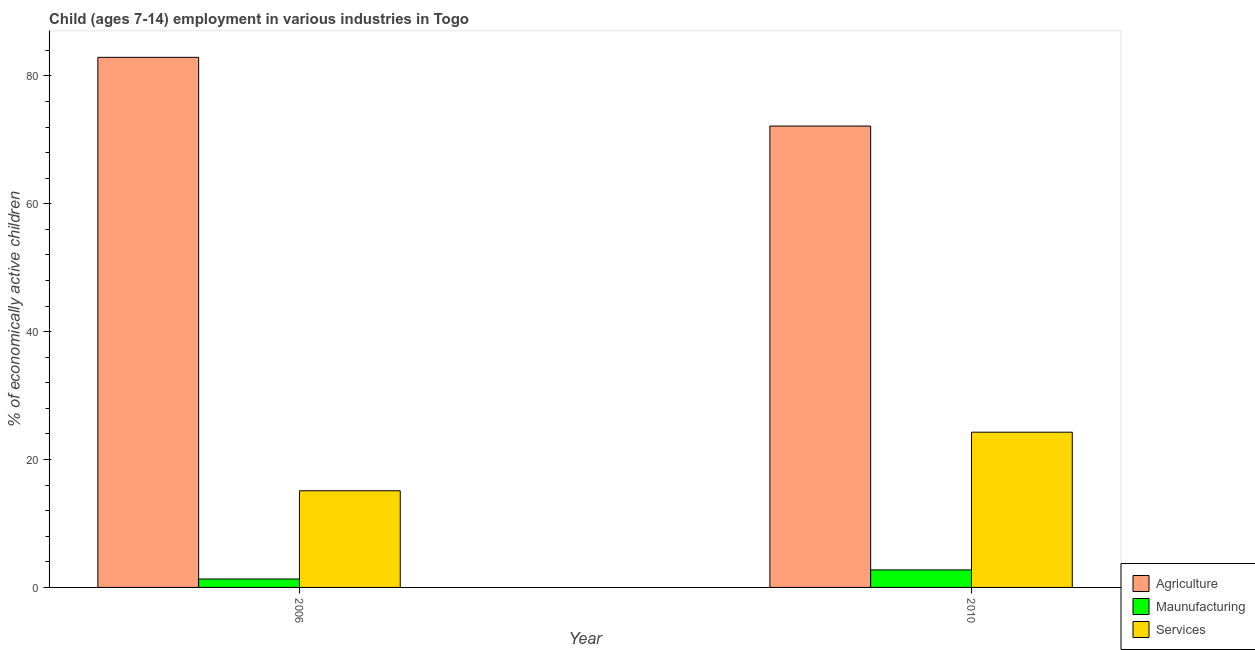How many different coloured bars are there?
Make the answer very short. 3. How many groups of bars are there?
Keep it short and to the point. 2. In how many cases, is the number of bars for a given year not equal to the number of legend labels?
Offer a terse response. 0. What is the percentage of economically active children in manufacturing in 2010?
Offer a very short reply. 2.74. Across all years, what is the maximum percentage of economically active children in agriculture?
Make the answer very short. 82.91. Across all years, what is the minimum percentage of economically active children in agriculture?
Offer a terse response. 72.16. In which year was the percentage of economically active children in agriculture minimum?
Provide a short and direct response. 2010. What is the total percentage of economically active children in services in the graph?
Keep it short and to the point. 39.4. What is the difference between the percentage of economically active children in services in 2006 and that in 2010?
Your answer should be compact. -9.16. What is the difference between the percentage of economically active children in manufacturing in 2010 and the percentage of economically active children in agriculture in 2006?
Make the answer very short. 1.42. What is the average percentage of economically active children in agriculture per year?
Your response must be concise. 77.53. In the year 2006, what is the difference between the percentage of economically active children in agriculture and percentage of economically active children in services?
Provide a succinct answer. 0. In how many years, is the percentage of economically active children in agriculture greater than 68 %?
Offer a terse response. 2. What is the ratio of the percentage of economically active children in services in 2006 to that in 2010?
Offer a terse response. 0.62. In how many years, is the percentage of economically active children in services greater than the average percentage of economically active children in services taken over all years?
Offer a very short reply. 1. What does the 2nd bar from the left in 2006 represents?
Offer a terse response. Maunufacturing. What does the 3rd bar from the right in 2010 represents?
Offer a terse response. Agriculture. Is it the case that in every year, the sum of the percentage of economically active children in agriculture and percentage of economically active children in manufacturing is greater than the percentage of economically active children in services?
Your response must be concise. Yes. How many years are there in the graph?
Your answer should be very brief. 2. Does the graph contain any zero values?
Offer a very short reply. No. Does the graph contain grids?
Provide a succinct answer. No. What is the title of the graph?
Offer a terse response. Child (ages 7-14) employment in various industries in Togo. Does "Financial account" appear as one of the legend labels in the graph?
Offer a very short reply. No. What is the label or title of the Y-axis?
Offer a terse response. % of economically active children. What is the % of economically active children of Agriculture in 2006?
Provide a succinct answer. 82.91. What is the % of economically active children in Maunufacturing in 2006?
Your answer should be very brief. 1.32. What is the % of economically active children in Services in 2006?
Keep it short and to the point. 15.12. What is the % of economically active children of Agriculture in 2010?
Offer a terse response. 72.16. What is the % of economically active children of Maunufacturing in 2010?
Your response must be concise. 2.74. What is the % of economically active children of Services in 2010?
Your answer should be compact. 24.28. Across all years, what is the maximum % of economically active children of Agriculture?
Make the answer very short. 82.91. Across all years, what is the maximum % of economically active children of Maunufacturing?
Ensure brevity in your answer.  2.74. Across all years, what is the maximum % of economically active children of Services?
Your answer should be very brief. 24.28. Across all years, what is the minimum % of economically active children in Agriculture?
Provide a short and direct response. 72.16. Across all years, what is the minimum % of economically active children in Maunufacturing?
Your response must be concise. 1.32. Across all years, what is the minimum % of economically active children in Services?
Make the answer very short. 15.12. What is the total % of economically active children of Agriculture in the graph?
Your response must be concise. 155.07. What is the total % of economically active children in Maunufacturing in the graph?
Give a very brief answer. 4.06. What is the total % of economically active children in Services in the graph?
Provide a succinct answer. 39.4. What is the difference between the % of economically active children of Agriculture in 2006 and that in 2010?
Offer a very short reply. 10.75. What is the difference between the % of economically active children in Maunufacturing in 2006 and that in 2010?
Your answer should be very brief. -1.42. What is the difference between the % of economically active children of Services in 2006 and that in 2010?
Your answer should be very brief. -9.16. What is the difference between the % of economically active children of Agriculture in 2006 and the % of economically active children of Maunufacturing in 2010?
Keep it short and to the point. 80.17. What is the difference between the % of economically active children in Agriculture in 2006 and the % of economically active children in Services in 2010?
Provide a short and direct response. 58.63. What is the difference between the % of economically active children of Maunufacturing in 2006 and the % of economically active children of Services in 2010?
Provide a short and direct response. -22.96. What is the average % of economically active children in Agriculture per year?
Ensure brevity in your answer.  77.53. What is the average % of economically active children of Maunufacturing per year?
Keep it short and to the point. 2.03. What is the average % of economically active children in Services per year?
Offer a terse response. 19.7. In the year 2006, what is the difference between the % of economically active children in Agriculture and % of economically active children in Maunufacturing?
Provide a succinct answer. 81.59. In the year 2006, what is the difference between the % of economically active children of Agriculture and % of economically active children of Services?
Give a very brief answer. 67.79. In the year 2010, what is the difference between the % of economically active children of Agriculture and % of economically active children of Maunufacturing?
Your response must be concise. 69.42. In the year 2010, what is the difference between the % of economically active children in Agriculture and % of economically active children in Services?
Provide a short and direct response. 47.88. In the year 2010, what is the difference between the % of economically active children in Maunufacturing and % of economically active children in Services?
Give a very brief answer. -21.54. What is the ratio of the % of economically active children of Agriculture in 2006 to that in 2010?
Ensure brevity in your answer.  1.15. What is the ratio of the % of economically active children in Maunufacturing in 2006 to that in 2010?
Ensure brevity in your answer.  0.48. What is the ratio of the % of economically active children of Services in 2006 to that in 2010?
Your answer should be compact. 0.62. What is the difference between the highest and the second highest % of economically active children of Agriculture?
Offer a very short reply. 10.75. What is the difference between the highest and the second highest % of economically active children in Maunufacturing?
Give a very brief answer. 1.42. What is the difference between the highest and the second highest % of economically active children in Services?
Make the answer very short. 9.16. What is the difference between the highest and the lowest % of economically active children of Agriculture?
Offer a very short reply. 10.75. What is the difference between the highest and the lowest % of economically active children of Maunufacturing?
Offer a terse response. 1.42. What is the difference between the highest and the lowest % of economically active children of Services?
Your answer should be compact. 9.16. 